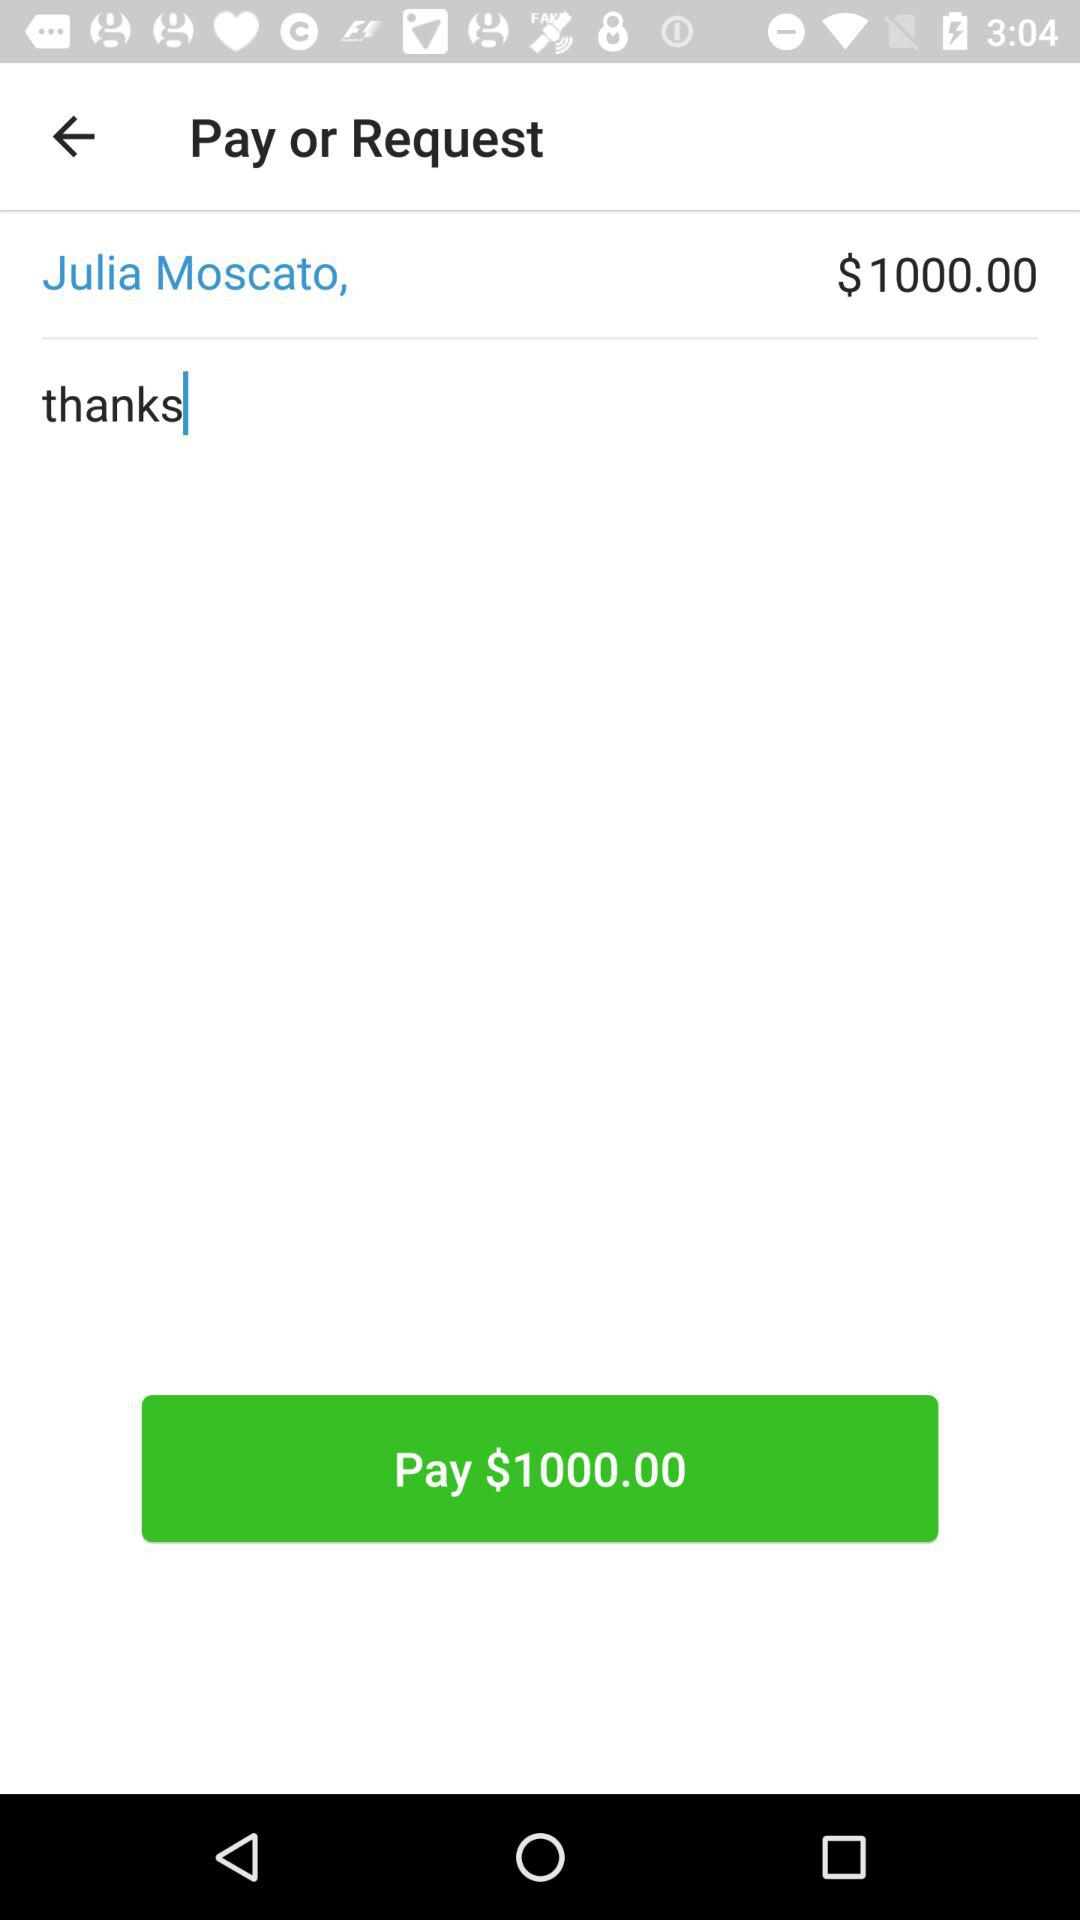How much money is being requested?
Answer the question using a single word or phrase. $1000.00 